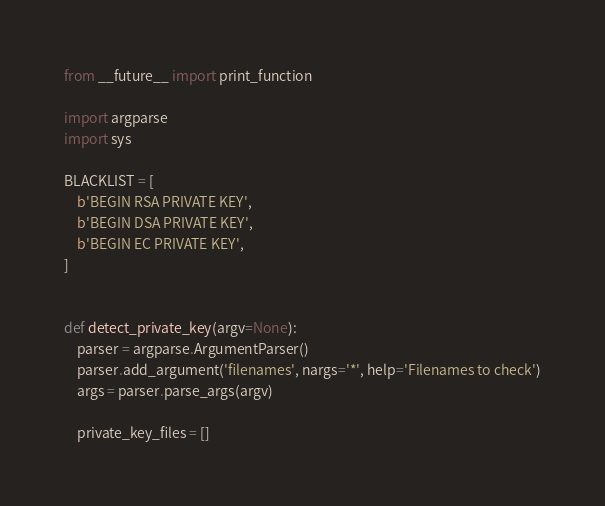Convert code to text. <code><loc_0><loc_0><loc_500><loc_500><_Python_>from __future__ import print_function

import argparse
import sys

BLACKLIST = [
    b'BEGIN RSA PRIVATE KEY',
    b'BEGIN DSA PRIVATE KEY',
    b'BEGIN EC PRIVATE KEY',
]


def detect_private_key(argv=None):
    parser = argparse.ArgumentParser()
    parser.add_argument('filenames', nargs='*', help='Filenames to check')
    args = parser.parse_args(argv)

    private_key_files = []
</code> 